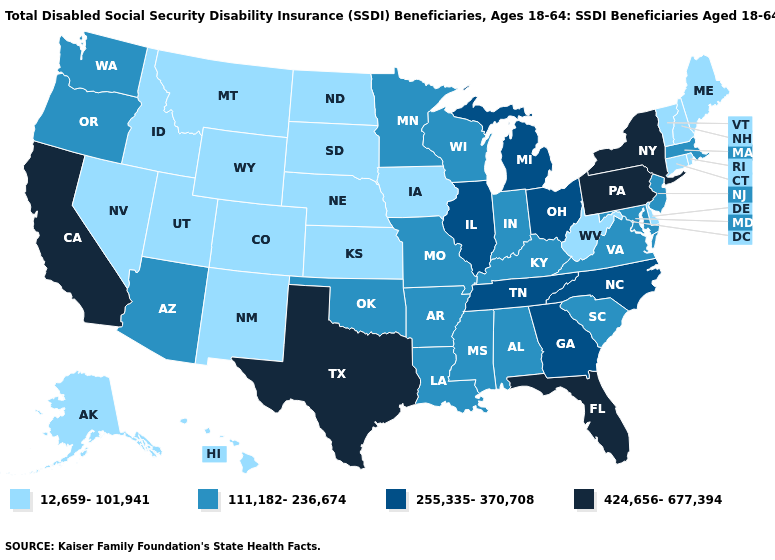Name the states that have a value in the range 111,182-236,674?
Give a very brief answer. Alabama, Arizona, Arkansas, Indiana, Kentucky, Louisiana, Maryland, Massachusetts, Minnesota, Mississippi, Missouri, New Jersey, Oklahoma, Oregon, South Carolina, Virginia, Washington, Wisconsin. What is the highest value in the Northeast ?
Write a very short answer. 424,656-677,394. Name the states that have a value in the range 111,182-236,674?
Be succinct. Alabama, Arizona, Arkansas, Indiana, Kentucky, Louisiana, Maryland, Massachusetts, Minnesota, Mississippi, Missouri, New Jersey, Oklahoma, Oregon, South Carolina, Virginia, Washington, Wisconsin. What is the highest value in the USA?
Be succinct. 424,656-677,394. Name the states that have a value in the range 111,182-236,674?
Give a very brief answer. Alabama, Arizona, Arkansas, Indiana, Kentucky, Louisiana, Maryland, Massachusetts, Minnesota, Mississippi, Missouri, New Jersey, Oklahoma, Oregon, South Carolina, Virginia, Washington, Wisconsin. What is the lowest value in the USA?
Short answer required. 12,659-101,941. Name the states that have a value in the range 111,182-236,674?
Be succinct. Alabama, Arizona, Arkansas, Indiana, Kentucky, Louisiana, Maryland, Massachusetts, Minnesota, Mississippi, Missouri, New Jersey, Oklahoma, Oregon, South Carolina, Virginia, Washington, Wisconsin. What is the highest value in the USA?
Short answer required. 424,656-677,394. Name the states that have a value in the range 12,659-101,941?
Be succinct. Alaska, Colorado, Connecticut, Delaware, Hawaii, Idaho, Iowa, Kansas, Maine, Montana, Nebraska, Nevada, New Hampshire, New Mexico, North Dakota, Rhode Island, South Dakota, Utah, Vermont, West Virginia, Wyoming. Does Rhode Island have the highest value in the USA?
Concise answer only. No. Is the legend a continuous bar?
Quick response, please. No. How many symbols are there in the legend?
Give a very brief answer. 4. What is the lowest value in the USA?
Give a very brief answer. 12,659-101,941. Which states have the lowest value in the MidWest?
Answer briefly. Iowa, Kansas, Nebraska, North Dakota, South Dakota. How many symbols are there in the legend?
Short answer required. 4. 